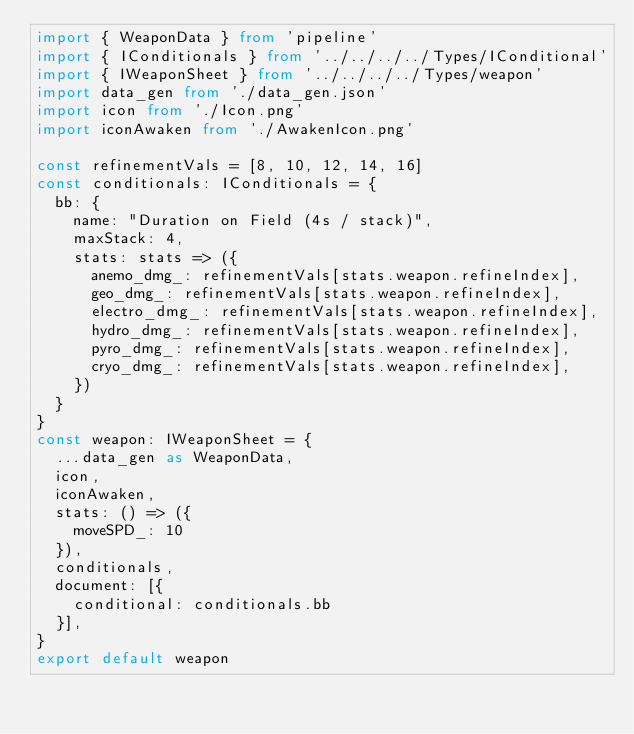Convert code to text. <code><loc_0><loc_0><loc_500><loc_500><_TypeScript_>import { WeaponData } from 'pipeline'
import { IConditionals } from '../../../../Types/IConditional'
import { IWeaponSheet } from '../../../../Types/weapon'
import data_gen from './data_gen.json'
import icon from './Icon.png'
import iconAwaken from './AwakenIcon.png'

const refinementVals = [8, 10, 12, 14, 16]
const conditionals: IConditionals = {
  bb: {
    name: "Duration on Field (4s / stack)",
    maxStack: 4,
    stats: stats => ({
      anemo_dmg_: refinementVals[stats.weapon.refineIndex],
      geo_dmg_: refinementVals[stats.weapon.refineIndex],
      electro_dmg_: refinementVals[stats.weapon.refineIndex],
      hydro_dmg_: refinementVals[stats.weapon.refineIndex],
      pyro_dmg_: refinementVals[stats.weapon.refineIndex],
      cryo_dmg_: refinementVals[stats.weapon.refineIndex],
    })
  }
}
const weapon: IWeaponSheet = {
  ...data_gen as WeaponData,
  icon,
  iconAwaken,
  stats: () => ({
    moveSPD_: 10
  }),
  conditionals,
  document: [{
    conditional: conditionals.bb
  }],
}
export default weapon</code> 